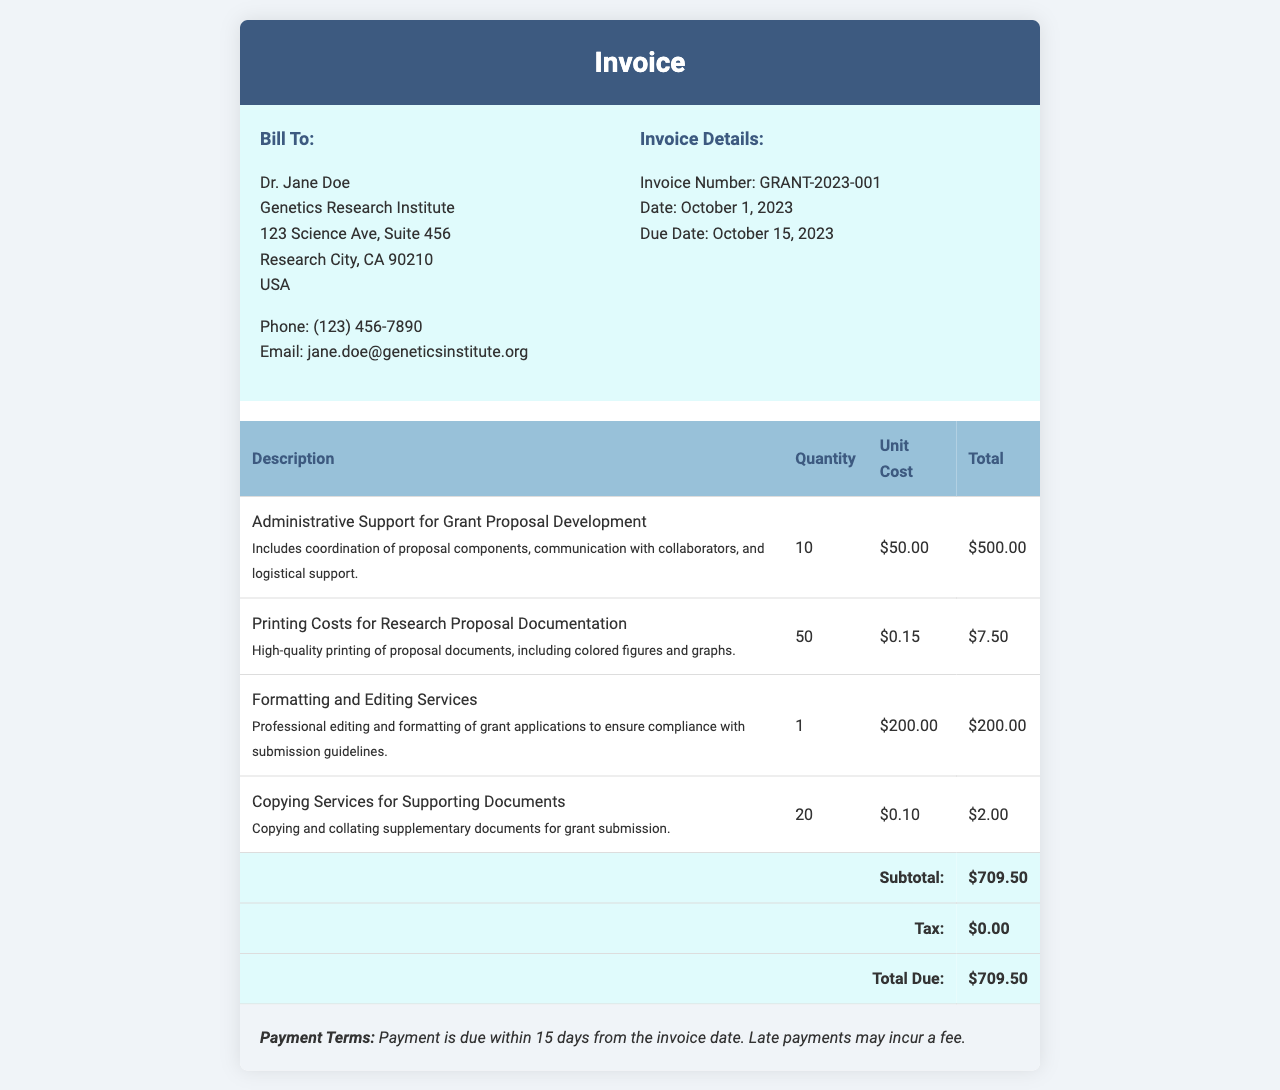What is the invoice number? The invoice number is provided under "Invoice Details" and is used for identifying this specific invoice.
Answer: GRANT-2023-001 What is the total due amount? The total due amount is located at the bottom of the invoice and represents the full amount owed after all charges.
Answer: $709.50 Who is the invoice billed to? The "Bill To" section lists the recipient of the invoice, vital for tracking and addressing payments.
Answer: Dr. Jane Doe What is the quantity of administrative support hours billed? The quantity indicates how many hours of administrative support have been documented in the invoice details.
Answer: 10 What date is the invoice due? The due date is critical for payment timelines and is specified in the invoice details section.
Answer: October 15, 2023 What are printing costs per document? This reflects the cost for printing research proposal documentation, a key expense in the invoice.
Answer: $0.15 How many total services are charged for formatting and editing? This number shows the singular service billed and reflects a one-time charge for specific services rendered.
Answer: 1 What description is provided for copying services? The description of services gives insight into what those charges entail, important for understanding the invoice breakdown.
Answer: Copying and collating supplementary documents for grant submission 